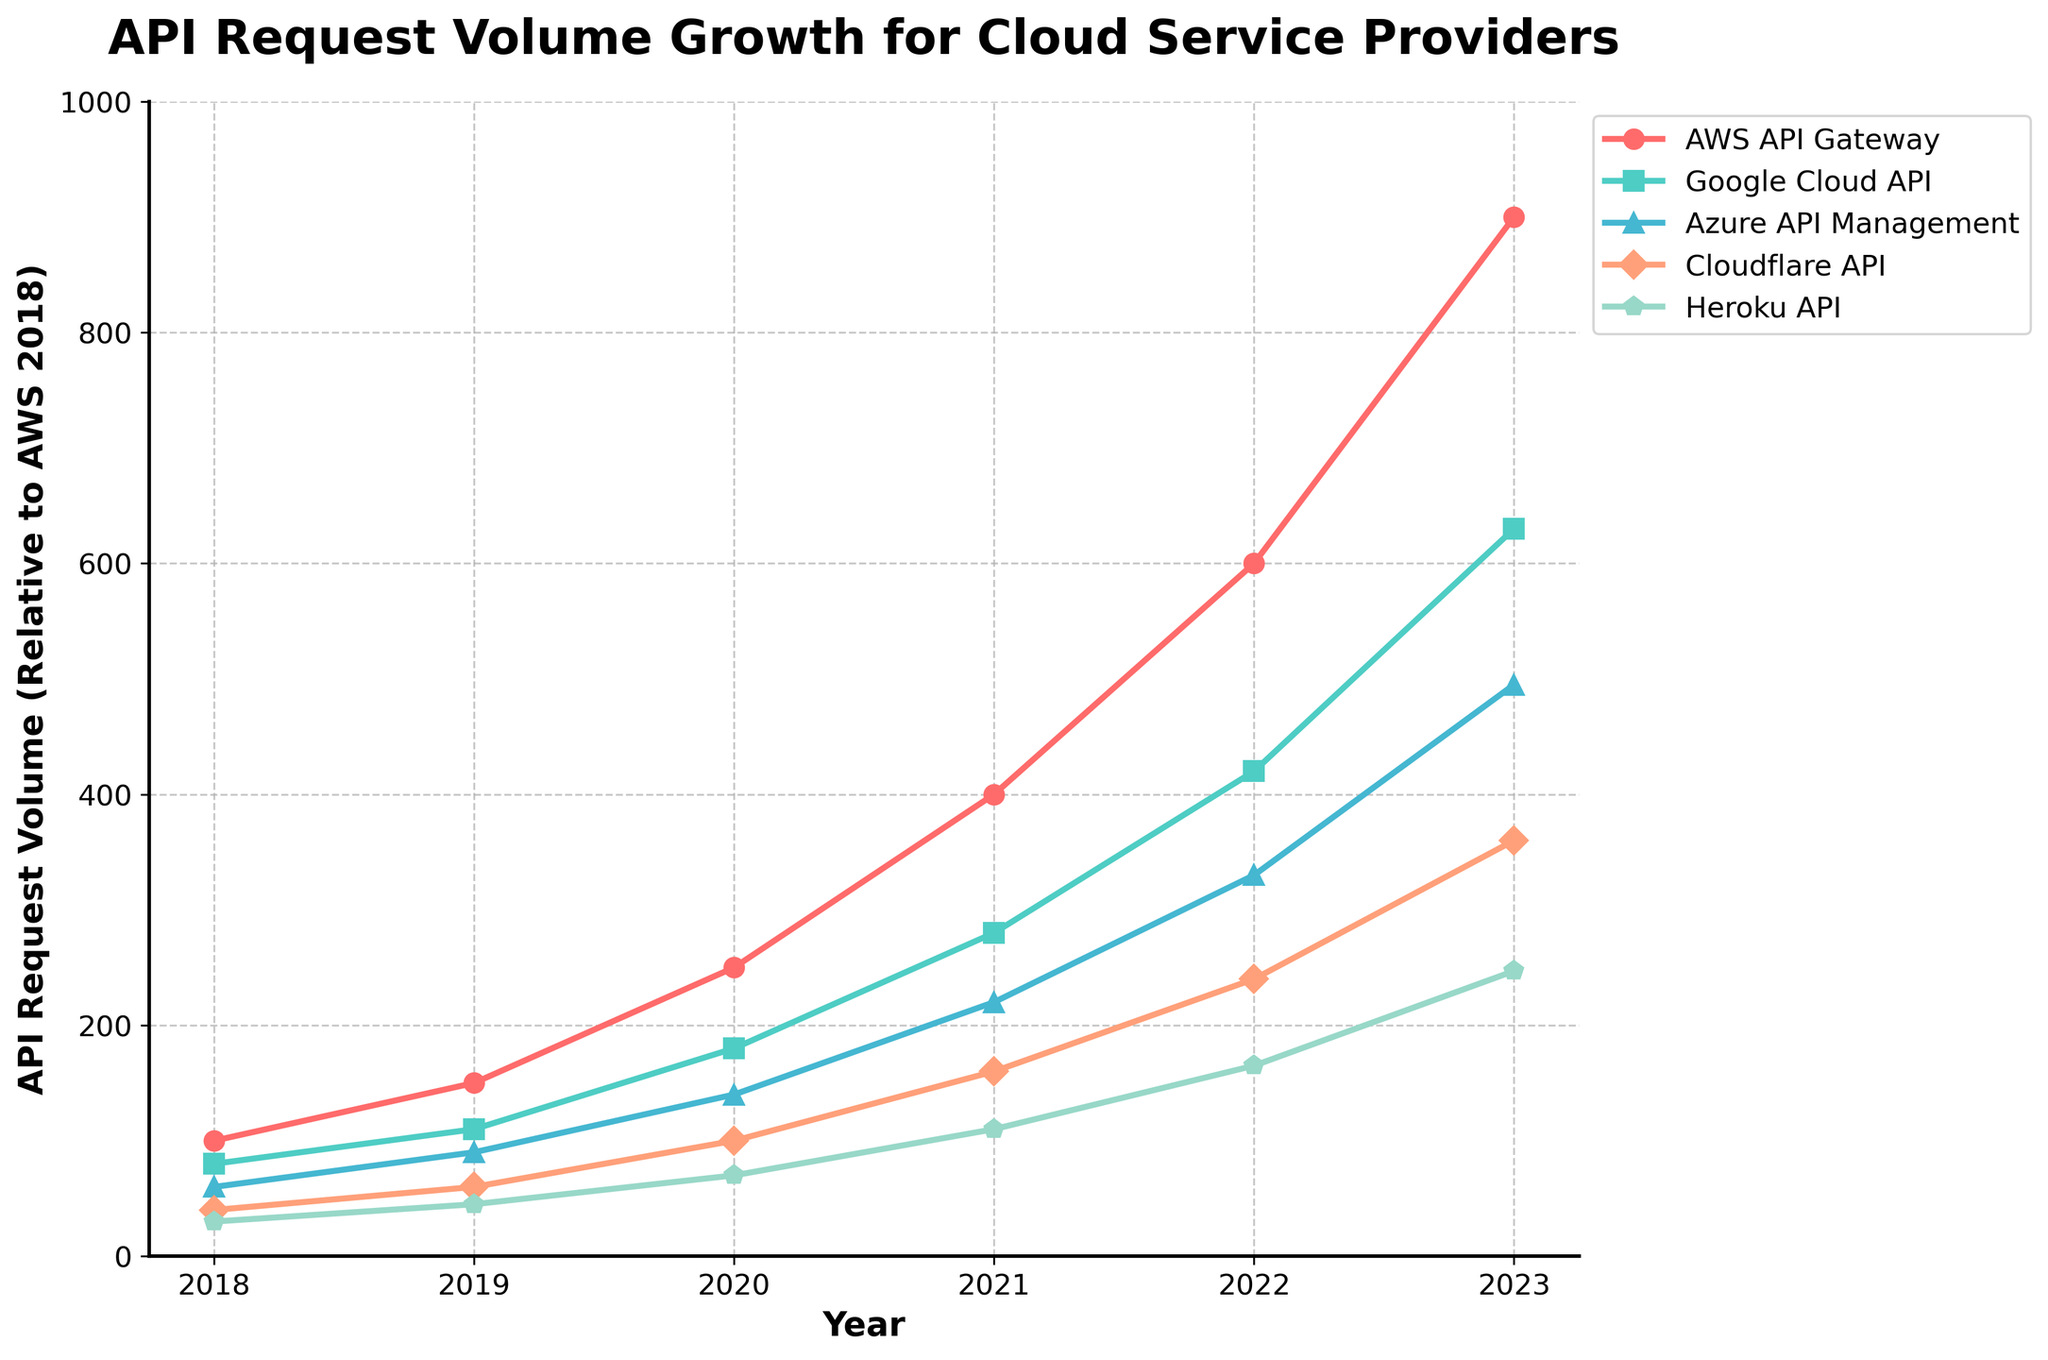What is the difference in API request volume between AWS API Gateway and Google Cloud API in 2023? To find the difference, subtract the API request volume of Google Cloud API from AWS API Gateway in 2023: 900 - 630 = 270
Answer: 270 Which cloud service provider has the highest growth in API request volume between 2018 and 2023? Compare the API request volumes for each provider in 2018 and 2023, and find the differences: 
- AWS API Gateway: 900 - 100 = 800
- Google Cloud API: 630 - 80 = 550
- Azure API Management: 495 - 60 = 435
- Cloudflare API: 360 - 40 = 320
- Heroku API: 247 - 30 = 217
AWS API Gateway has the highest growth with 800.
Answer: AWS API Gateway What's the average API request volume for all cloud service providers in 2023? First, sum the API request volumes of all providers in 2023: 900 + 630 + 495 + 360 + 247 = 2632. Then, divide by the number of providers: 2632 / 5 = 526.4
Answer: 526.4 Which cloud service provider had the least API request volume in 2021? Observe the API request volumes for each provider in 2021: 
- AWS API Gateway: 400
- Google Cloud API: 280
- Azure API Management: 220
- Cloudflare API: 160
- Heroku API: 110
Heroku API had the least with 110.
Answer: Heroku API Between which two consecutive years did Cloudflare API experience the highest growth in request volume? Calculate the year-over-year growth for Cloudflare API:
- 2019-2018: 60 - 40 = 20
- 2020-2019: 100 - 60 = 40
- 2021-2020: 160 - 100 = 60
- 2022-2021: 240 - 160 = 80
- 2023-2022: 360 - 240 = 120
The highest growth of 120 occurred between 2022 and 2023.
Answer: 2022 and 2023 How did the API request volume of Azure API Management compare to Heroku API over the years? Compare API request volumes year by year:
- 2018: Azure (60) > Heroku (30)
- 2019: Azure (90) > Heroku (45)
- 2020: Azure (140) > Heroku (70)
- 2021: Azure (220) > Heroku (110)
- 2022: Azure (330) > Heroku (165)
- 2023: Azure (495) > Heroku (247)
Azure API Management always had a higher API request volume than Heroku API every year.
Answer: Azure API Management > Heroku API What is the approximate ratio of AWS API Gateway volume to Cloudflare API volume in 2020? In 2020, the API request volumes are:
- AWS API Gateway: 250
- Cloudflare API: 100
The ratio is approximately 250 / 100 = 2.5
Answer: 2.5 